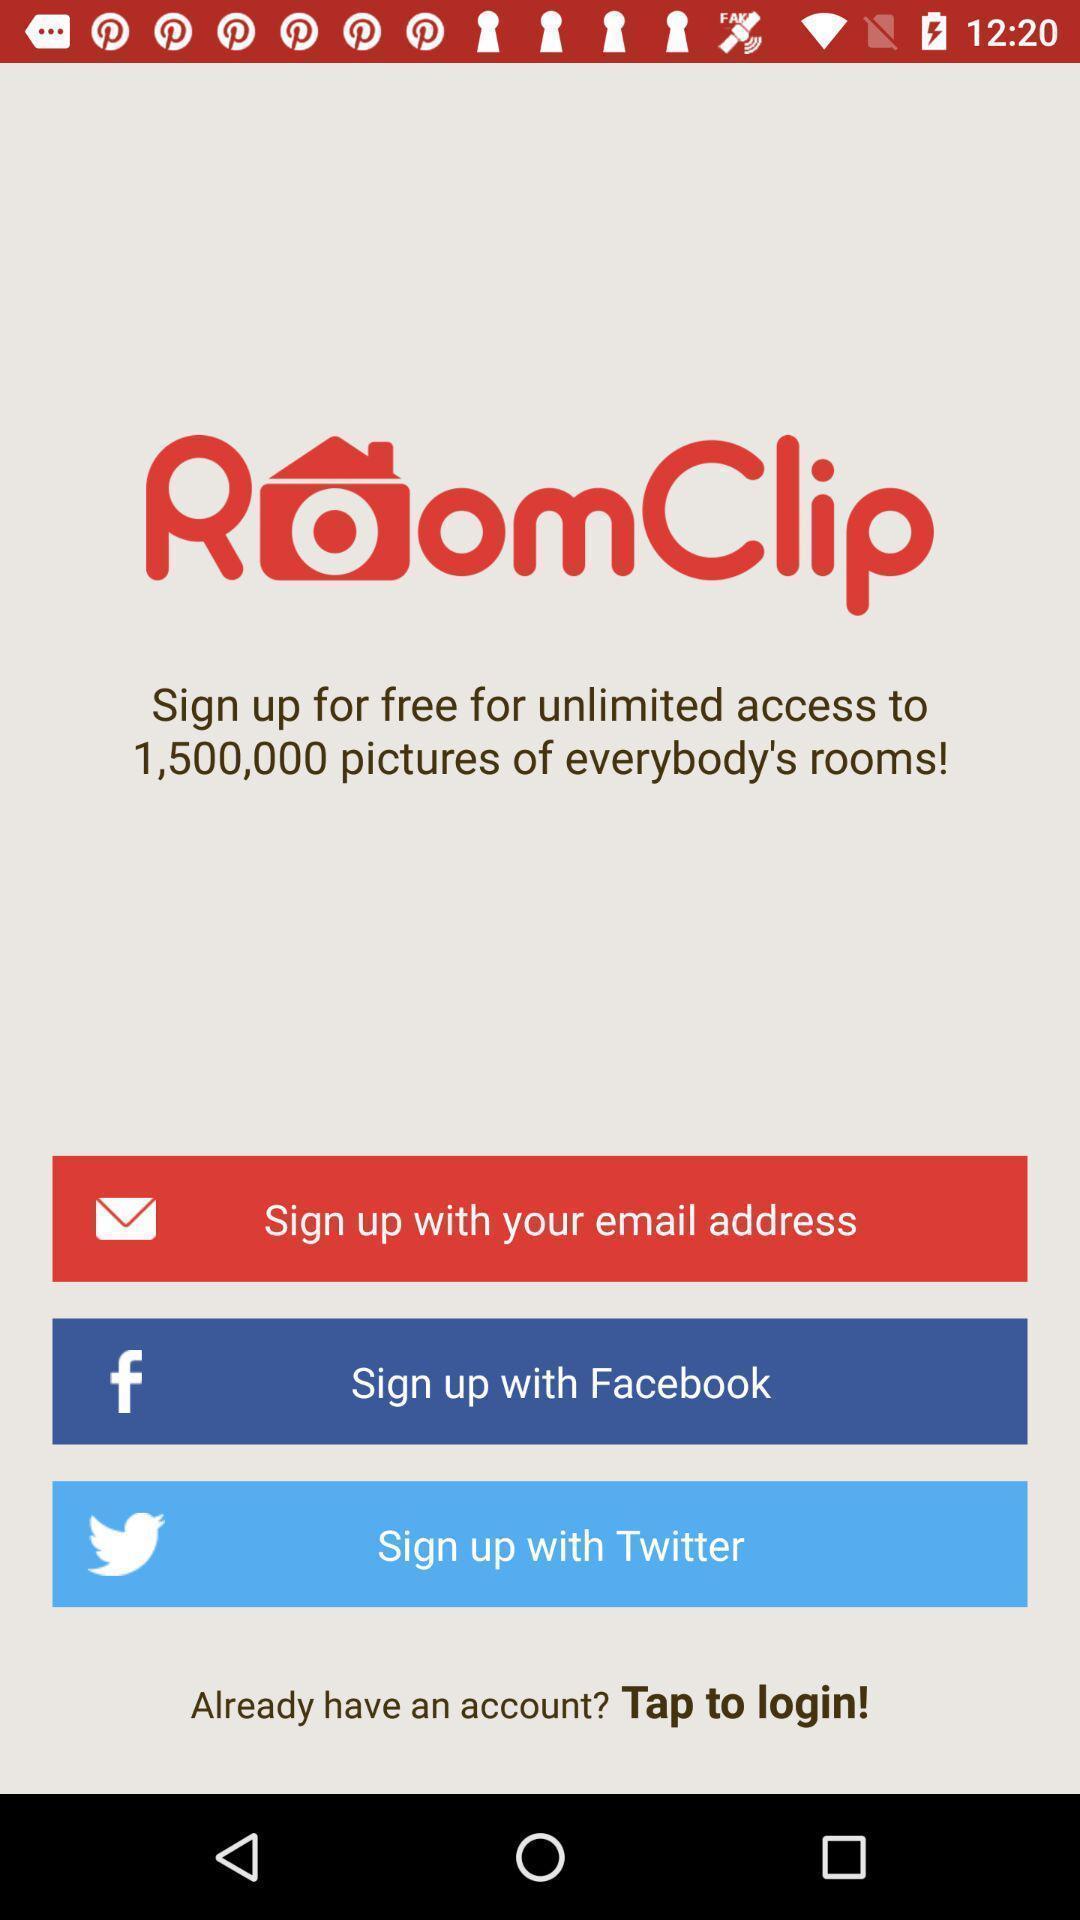Summarize the information in this screenshot. Welcome page of a room s interior decorations app. 